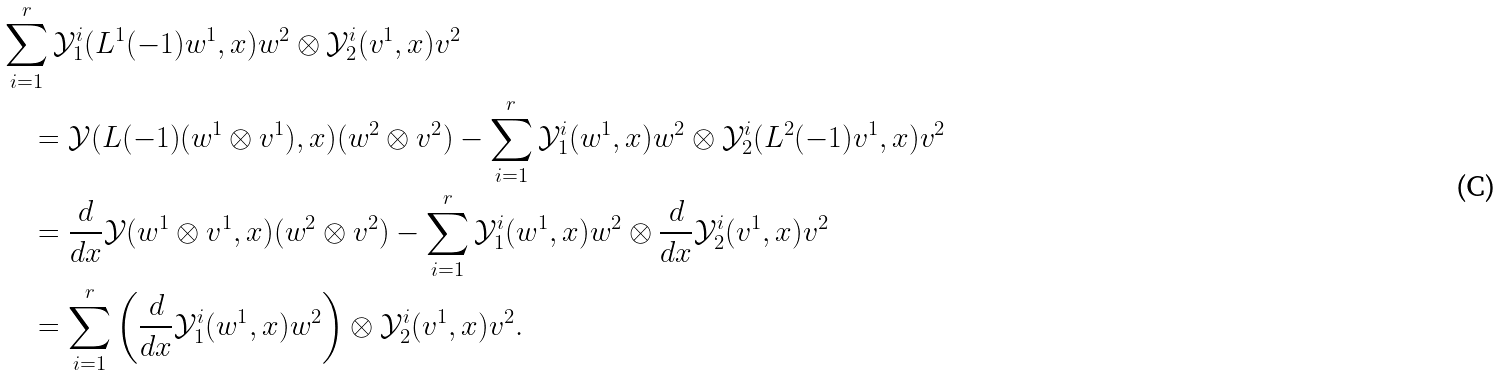Convert formula to latex. <formula><loc_0><loc_0><loc_500><loc_500>& \sum _ { i = 1 } ^ { r } \mathcal { Y } _ { 1 } ^ { i } ( L ^ { 1 } ( - 1 ) w ^ { 1 } , x ) w ^ { 2 } \otimes \mathcal { Y } _ { 2 } ^ { i } ( v ^ { 1 } , x ) v ^ { 2 } \\ & \quad = \mathcal { Y } ( L ( - 1 ) ( w ^ { 1 } \otimes v ^ { 1 } ) , x ) ( w ^ { 2 } \otimes v ^ { 2 } ) - \sum _ { i = 1 } ^ { r } \mathcal { Y } _ { 1 } ^ { i } ( w ^ { 1 } , x ) w ^ { 2 } \otimes \mathcal { Y } _ { 2 } ^ { i } ( L ^ { 2 } ( - 1 ) v ^ { 1 } , x ) v ^ { 2 } \\ & \quad = \frac { d } { d x } \mathcal { Y } ( w ^ { 1 } \otimes v ^ { 1 } , x ) ( w ^ { 2 } \otimes v ^ { 2 } ) - \sum _ { i = 1 } ^ { r } \mathcal { Y } _ { 1 } ^ { i } ( w ^ { 1 } , x ) w ^ { 2 } \otimes \frac { d } { d x } \mathcal { Y } _ { 2 } ^ { i } ( v ^ { 1 } , x ) v ^ { 2 } \\ & \quad = \sum _ { i = 1 } ^ { r } \left ( \frac { d } { d x } \mathcal { Y } _ { 1 } ^ { i } ( w ^ { 1 } , x ) w ^ { 2 } \right ) \otimes \mathcal { Y } _ { 2 } ^ { i } ( v ^ { 1 } , x ) v ^ { 2 } .</formula> 